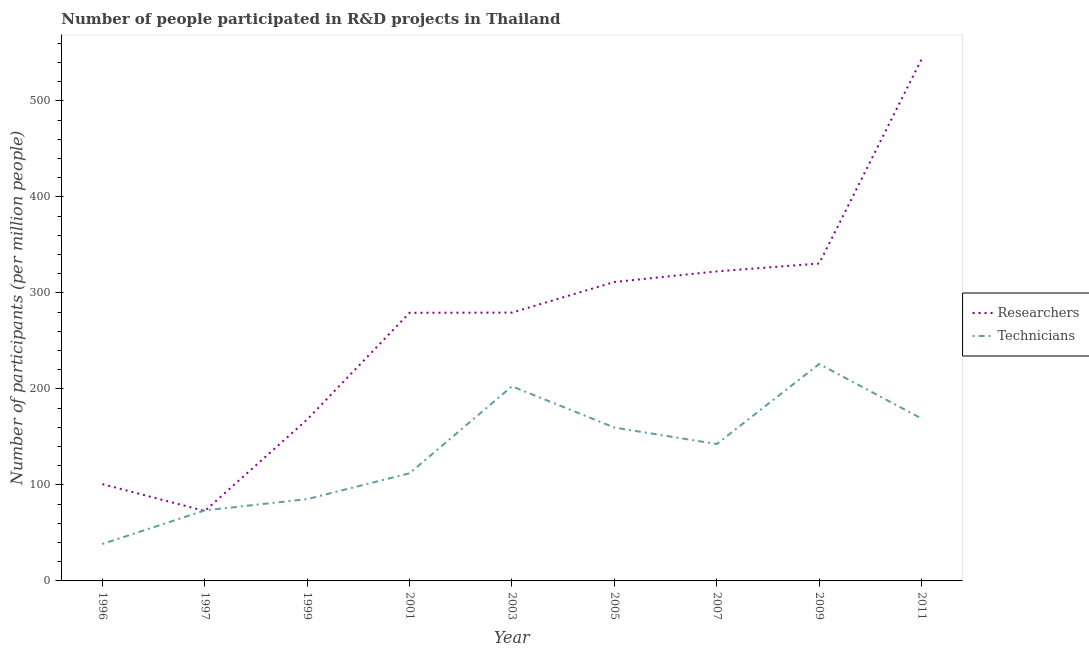Is the number of lines equal to the number of legend labels?
Provide a short and direct response. Yes. What is the number of technicians in 1997?
Your response must be concise. 73.43. Across all years, what is the maximum number of technicians?
Provide a succinct answer. 225.94. Across all years, what is the minimum number of researchers?
Keep it short and to the point. 72.82. What is the total number of researchers in the graph?
Your answer should be very brief. 2408.29. What is the difference between the number of technicians in 1996 and that in 2003?
Give a very brief answer. -164.25. What is the difference between the number of technicians in 1997 and the number of researchers in 2011?
Offer a terse response. -470.04. What is the average number of researchers per year?
Make the answer very short. 267.59. In the year 1996, what is the difference between the number of researchers and number of technicians?
Your response must be concise. 62.38. What is the ratio of the number of researchers in 1999 to that in 2007?
Provide a succinct answer. 0.52. Is the number of researchers in 1997 less than that in 2007?
Offer a terse response. Yes. What is the difference between the highest and the second highest number of technicians?
Offer a very short reply. 23.23. What is the difference between the highest and the lowest number of researchers?
Make the answer very short. 470.65. In how many years, is the number of technicians greater than the average number of technicians taken over all years?
Make the answer very short. 5. Does the number of technicians monotonically increase over the years?
Your answer should be compact. No. Is the number of researchers strictly greater than the number of technicians over the years?
Provide a succinct answer. No. Is the number of technicians strictly less than the number of researchers over the years?
Your answer should be very brief. No. What is the difference between two consecutive major ticks on the Y-axis?
Give a very brief answer. 100. Does the graph contain grids?
Ensure brevity in your answer.  No. Where does the legend appear in the graph?
Make the answer very short. Center right. How are the legend labels stacked?
Offer a very short reply. Vertical. What is the title of the graph?
Your answer should be compact. Number of people participated in R&D projects in Thailand. What is the label or title of the X-axis?
Your answer should be very brief. Year. What is the label or title of the Y-axis?
Your answer should be very brief. Number of participants (per million people). What is the Number of participants (per million people) of Researchers in 1996?
Make the answer very short. 100.84. What is the Number of participants (per million people) of Technicians in 1996?
Offer a very short reply. 38.46. What is the Number of participants (per million people) of Researchers in 1997?
Your answer should be compact. 72.82. What is the Number of participants (per million people) in Technicians in 1997?
Provide a short and direct response. 73.43. What is the Number of participants (per million people) of Researchers in 1999?
Keep it short and to the point. 168.1. What is the Number of participants (per million people) in Technicians in 1999?
Provide a short and direct response. 85.21. What is the Number of participants (per million people) in Researchers in 2001?
Ensure brevity in your answer.  279.27. What is the Number of participants (per million people) of Technicians in 2001?
Your answer should be compact. 112.12. What is the Number of participants (per million people) of Researchers in 2003?
Offer a very short reply. 279.46. What is the Number of participants (per million people) in Technicians in 2003?
Offer a terse response. 202.71. What is the Number of participants (per million people) of Researchers in 2005?
Ensure brevity in your answer.  311.34. What is the Number of participants (per million people) in Technicians in 2005?
Your answer should be very brief. 159.72. What is the Number of participants (per million people) of Researchers in 2007?
Offer a very short reply. 322.39. What is the Number of participants (per million people) of Technicians in 2007?
Offer a terse response. 142.58. What is the Number of participants (per million people) in Researchers in 2009?
Give a very brief answer. 330.59. What is the Number of participants (per million people) in Technicians in 2009?
Ensure brevity in your answer.  225.94. What is the Number of participants (per million people) in Researchers in 2011?
Give a very brief answer. 543.47. What is the Number of participants (per million people) in Technicians in 2011?
Give a very brief answer. 169.1. Across all years, what is the maximum Number of participants (per million people) in Researchers?
Give a very brief answer. 543.47. Across all years, what is the maximum Number of participants (per million people) of Technicians?
Your answer should be compact. 225.94. Across all years, what is the minimum Number of participants (per million people) in Researchers?
Provide a succinct answer. 72.82. Across all years, what is the minimum Number of participants (per million people) of Technicians?
Give a very brief answer. 38.46. What is the total Number of participants (per million people) of Researchers in the graph?
Give a very brief answer. 2408.29. What is the total Number of participants (per million people) of Technicians in the graph?
Your answer should be compact. 1209.28. What is the difference between the Number of participants (per million people) of Researchers in 1996 and that in 1997?
Your response must be concise. 28.01. What is the difference between the Number of participants (per million people) of Technicians in 1996 and that in 1997?
Offer a terse response. -34.97. What is the difference between the Number of participants (per million people) in Researchers in 1996 and that in 1999?
Provide a succinct answer. -67.27. What is the difference between the Number of participants (per million people) of Technicians in 1996 and that in 1999?
Offer a terse response. -46.75. What is the difference between the Number of participants (per million people) of Researchers in 1996 and that in 2001?
Provide a short and direct response. -178.43. What is the difference between the Number of participants (per million people) of Technicians in 1996 and that in 2001?
Keep it short and to the point. -73.66. What is the difference between the Number of participants (per million people) in Researchers in 1996 and that in 2003?
Your answer should be very brief. -178.63. What is the difference between the Number of participants (per million people) in Technicians in 1996 and that in 2003?
Offer a very short reply. -164.25. What is the difference between the Number of participants (per million people) in Researchers in 1996 and that in 2005?
Make the answer very short. -210.5. What is the difference between the Number of participants (per million people) in Technicians in 1996 and that in 2005?
Your response must be concise. -121.26. What is the difference between the Number of participants (per million people) in Researchers in 1996 and that in 2007?
Your answer should be compact. -221.56. What is the difference between the Number of participants (per million people) of Technicians in 1996 and that in 2007?
Ensure brevity in your answer.  -104.12. What is the difference between the Number of participants (per million people) of Researchers in 1996 and that in 2009?
Provide a short and direct response. -229.75. What is the difference between the Number of participants (per million people) in Technicians in 1996 and that in 2009?
Your answer should be compact. -187.48. What is the difference between the Number of participants (per million people) in Researchers in 1996 and that in 2011?
Ensure brevity in your answer.  -442.64. What is the difference between the Number of participants (per million people) in Technicians in 1996 and that in 2011?
Provide a short and direct response. -130.63. What is the difference between the Number of participants (per million people) of Researchers in 1997 and that in 1999?
Give a very brief answer. -95.28. What is the difference between the Number of participants (per million people) of Technicians in 1997 and that in 1999?
Offer a terse response. -11.78. What is the difference between the Number of participants (per million people) of Researchers in 1997 and that in 2001?
Your answer should be compact. -206.45. What is the difference between the Number of participants (per million people) in Technicians in 1997 and that in 2001?
Your answer should be compact. -38.69. What is the difference between the Number of participants (per million people) of Researchers in 1997 and that in 2003?
Offer a very short reply. -206.64. What is the difference between the Number of participants (per million people) in Technicians in 1997 and that in 2003?
Provide a short and direct response. -129.28. What is the difference between the Number of participants (per million people) in Researchers in 1997 and that in 2005?
Your answer should be compact. -238.52. What is the difference between the Number of participants (per million people) of Technicians in 1997 and that in 2005?
Ensure brevity in your answer.  -86.29. What is the difference between the Number of participants (per million people) of Researchers in 1997 and that in 2007?
Ensure brevity in your answer.  -249.57. What is the difference between the Number of participants (per million people) in Technicians in 1997 and that in 2007?
Your answer should be compact. -69.15. What is the difference between the Number of participants (per million people) of Researchers in 1997 and that in 2009?
Keep it short and to the point. -257.77. What is the difference between the Number of participants (per million people) of Technicians in 1997 and that in 2009?
Ensure brevity in your answer.  -152.51. What is the difference between the Number of participants (per million people) of Researchers in 1997 and that in 2011?
Offer a terse response. -470.65. What is the difference between the Number of participants (per million people) of Technicians in 1997 and that in 2011?
Your answer should be very brief. -95.66. What is the difference between the Number of participants (per million people) of Researchers in 1999 and that in 2001?
Offer a very short reply. -111.17. What is the difference between the Number of participants (per million people) in Technicians in 1999 and that in 2001?
Your answer should be compact. -26.91. What is the difference between the Number of participants (per million people) in Researchers in 1999 and that in 2003?
Make the answer very short. -111.36. What is the difference between the Number of participants (per million people) in Technicians in 1999 and that in 2003?
Give a very brief answer. -117.5. What is the difference between the Number of participants (per million people) in Researchers in 1999 and that in 2005?
Your answer should be very brief. -143.24. What is the difference between the Number of participants (per million people) of Technicians in 1999 and that in 2005?
Your answer should be very brief. -74.51. What is the difference between the Number of participants (per million people) in Researchers in 1999 and that in 2007?
Your response must be concise. -154.29. What is the difference between the Number of participants (per million people) in Technicians in 1999 and that in 2007?
Your response must be concise. -57.37. What is the difference between the Number of participants (per million people) in Researchers in 1999 and that in 2009?
Offer a very short reply. -162.48. What is the difference between the Number of participants (per million people) in Technicians in 1999 and that in 2009?
Give a very brief answer. -140.73. What is the difference between the Number of participants (per million people) in Researchers in 1999 and that in 2011?
Provide a succinct answer. -375.37. What is the difference between the Number of participants (per million people) in Technicians in 1999 and that in 2011?
Make the answer very short. -83.88. What is the difference between the Number of participants (per million people) in Researchers in 2001 and that in 2003?
Provide a succinct answer. -0.19. What is the difference between the Number of participants (per million people) of Technicians in 2001 and that in 2003?
Make the answer very short. -90.59. What is the difference between the Number of participants (per million people) in Researchers in 2001 and that in 2005?
Keep it short and to the point. -32.07. What is the difference between the Number of participants (per million people) of Technicians in 2001 and that in 2005?
Make the answer very short. -47.6. What is the difference between the Number of participants (per million people) of Researchers in 2001 and that in 2007?
Keep it short and to the point. -43.12. What is the difference between the Number of participants (per million people) of Technicians in 2001 and that in 2007?
Ensure brevity in your answer.  -30.47. What is the difference between the Number of participants (per million people) of Researchers in 2001 and that in 2009?
Your answer should be compact. -51.32. What is the difference between the Number of participants (per million people) in Technicians in 2001 and that in 2009?
Your response must be concise. -113.82. What is the difference between the Number of participants (per million people) of Researchers in 2001 and that in 2011?
Make the answer very short. -264.2. What is the difference between the Number of participants (per million people) in Technicians in 2001 and that in 2011?
Provide a short and direct response. -56.98. What is the difference between the Number of participants (per million people) of Researchers in 2003 and that in 2005?
Keep it short and to the point. -31.88. What is the difference between the Number of participants (per million people) in Technicians in 2003 and that in 2005?
Provide a succinct answer. 42.99. What is the difference between the Number of participants (per million people) in Researchers in 2003 and that in 2007?
Your answer should be very brief. -42.93. What is the difference between the Number of participants (per million people) in Technicians in 2003 and that in 2007?
Your answer should be compact. 60.12. What is the difference between the Number of participants (per million people) of Researchers in 2003 and that in 2009?
Keep it short and to the point. -51.12. What is the difference between the Number of participants (per million people) in Technicians in 2003 and that in 2009?
Provide a succinct answer. -23.23. What is the difference between the Number of participants (per million people) in Researchers in 2003 and that in 2011?
Your response must be concise. -264.01. What is the difference between the Number of participants (per million people) of Technicians in 2003 and that in 2011?
Offer a very short reply. 33.61. What is the difference between the Number of participants (per million people) of Researchers in 2005 and that in 2007?
Give a very brief answer. -11.06. What is the difference between the Number of participants (per million people) of Technicians in 2005 and that in 2007?
Your answer should be compact. 17.14. What is the difference between the Number of participants (per million people) in Researchers in 2005 and that in 2009?
Offer a very short reply. -19.25. What is the difference between the Number of participants (per million people) of Technicians in 2005 and that in 2009?
Provide a succinct answer. -66.22. What is the difference between the Number of participants (per million people) of Researchers in 2005 and that in 2011?
Provide a short and direct response. -232.14. What is the difference between the Number of participants (per million people) of Technicians in 2005 and that in 2011?
Offer a terse response. -9.37. What is the difference between the Number of participants (per million people) of Researchers in 2007 and that in 2009?
Keep it short and to the point. -8.19. What is the difference between the Number of participants (per million people) in Technicians in 2007 and that in 2009?
Provide a short and direct response. -83.36. What is the difference between the Number of participants (per million people) in Researchers in 2007 and that in 2011?
Ensure brevity in your answer.  -221.08. What is the difference between the Number of participants (per million people) in Technicians in 2007 and that in 2011?
Provide a succinct answer. -26.51. What is the difference between the Number of participants (per million people) in Researchers in 2009 and that in 2011?
Offer a very short reply. -212.89. What is the difference between the Number of participants (per million people) of Technicians in 2009 and that in 2011?
Keep it short and to the point. 56.85. What is the difference between the Number of participants (per million people) in Researchers in 1996 and the Number of participants (per million people) in Technicians in 1997?
Make the answer very short. 27.4. What is the difference between the Number of participants (per million people) of Researchers in 1996 and the Number of participants (per million people) of Technicians in 1999?
Your answer should be compact. 15.62. What is the difference between the Number of participants (per million people) in Researchers in 1996 and the Number of participants (per million people) in Technicians in 2001?
Your response must be concise. -11.28. What is the difference between the Number of participants (per million people) in Researchers in 1996 and the Number of participants (per million people) in Technicians in 2003?
Provide a short and direct response. -101.87. What is the difference between the Number of participants (per million people) of Researchers in 1996 and the Number of participants (per million people) of Technicians in 2005?
Offer a terse response. -58.89. What is the difference between the Number of participants (per million people) in Researchers in 1996 and the Number of participants (per million people) in Technicians in 2007?
Make the answer very short. -41.75. What is the difference between the Number of participants (per million people) in Researchers in 1996 and the Number of participants (per million people) in Technicians in 2009?
Provide a succinct answer. -125.1. What is the difference between the Number of participants (per million people) in Researchers in 1996 and the Number of participants (per million people) in Technicians in 2011?
Keep it short and to the point. -68.26. What is the difference between the Number of participants (per million people) in Researchers in 1997 and the Number of participants (per million people) in Technicians in 1999?
Make the answer very short. -12.39. What is the difference between the Number of participants (per million people) of Researchers in 1997 and the Number of participants (per million people) of Technicians in 2001?
Your answer should be compact. -39.3. What is the difference between the Number of participants (per million people) of Researchers in 1997 and the Number of participants (per million people) of Technicians in 2003?
Offer a terse response. -129.89. What is the difference between the Number of participants (per million people) of Researchers in 1997 and the Number of participants (per million people) of Technicians in 2005?
Keep it short and to the point. -86.9. What is the difference between the Number of participants (per million people) in Researchers in 1997 and the Number of participants (per million people) in Technicians in 2007?
Your answer should be compact. -69.76. What is the difference between the Number of participants (per million people) in Researchers in 1997 and the Number of participants (per million people) in Technicians in 2009?
Your answer should be very brief. -153.12. What is the difference between the Number of participants (per million people) of Researchers in 1997 and the Number of participants (per million people) of Technicians in 2011?
Offer a very short reply. -96.27. What is the difference between the Number of participants (per million people) in Researchers in 1999 and the Number of participants (per million people) in Technicians in 2001?
Your answer should be very brief. 55.98. What is the difference between the Number of participants (per million people) in Researchers in 1999 and the Number of participants (per million people) in Technicians in 2003?
Keep it short and to the point. -34.61. What is the difference between the Number of participants (per million people) in Researchers in 1999 and the Number of participants (per million people) in Technicians in 2005?
Your response must be concise. 8.38. What is the difference between the Number of participants (per million people) in Researchers in 1999 and the Number of participants (per million people) in Technicians in 2007?
Make the answer very short. 25.52. What is the difference between the Number of participants (per million people) of Researchers in 1999 and the Number of participants (per million people) of Technicians in 2009?
Your response must be concise. -57.84. What is the difference between the Number of participants (per million people) of Researchers in 1999 and the Number of participants (per million people) of Technicians in 2011?
Ensure brevity in your answer.  -0.99. What is the difference between the Number of participants (per million people) in Researchers in 2001 and the Number of participants (per million people) in Technicians in 2003?
Ensure brevity in your answer.  76.56. What is the difference between the Number of participants (per million people) in Researchers in 2001 and the Number of participants (per million people) in Technicians in 2005?
Your response must be concise. 119.55. What is the difference between the Number of participants (per million people) in Researchers in 2001 and the Number of participants (per million people) in Technicians in 2007?
Your response must be concise. 136.69. What is the difference between the Number of participants (per million people) in Researchers in 2001 and the Number of participants (per million people) in Technicians in 2009?
Your answer should be compact. 53.33. What is the difference between the Number of participants (per million people) in Researchers in 2001 and the Number of participants (per million people) in Technicians in 2011?
Your response must be concise. 110.17. What is the difference between the Number of participants (per million people) in Researchers in 2003 and the Number of participants (per million people) in Technicians in 2005?
Offer a terse response. 119.74. What is the difference between the Number of participants (per million people) of Researchers in 2003 and the Number of participants (per million people) of Technicians in 2007?
Provide a short and direct response. 136.88. What is the difference between the Number of participants (per million people) in Researchers in 2003 and the Number of participants (per million people) in Technicians in 2009?
Offer a very short reply. 53.52. What is the difference between the Number of participants (per million people) in Researchers in 2003 and the Number of participants (per million people) in Technicians in 2011?
Your answer should be compact. 110.37. What is the difference between the Number of participants (per million people) in Researchers in 2005 and the Number of participants (per million people) in Technicians in 2007?
Give a very brief answer. 168.75. What is the difference between the Number of participants (per million people) in Researchers in 2005 and the Number of participants (per million people) in Technicians in 2009?
Provide a short and direct response. 85.4. What is the difference between the Number of participants (per million people) in Researchers in 2005 and the Number of participants (per million people) in Technicians in 2011?
Your answer should be compact. 142.24. What is the difference between the Number of participants (per million people) in Researchers in 2007 and the Number of participants (per million people) in Technicians in 2009?
Keep it short and to the point. 96.45. What is the difference between the Number of participants (per million people) of Researchers in 2007 and the Number of participants (per million people) of Technicians in 2011?
Make the answer very short. 153.3. What is the difference between the Number of participants (per million people) in Researchers in 2009 and the Number of participants (per million people) in Technicians in 2011?
Your answer should be compact. 161.49. What is the average Number of participants (per million people) of Researchers per year?
Give a very brief answer. 267.59. What is the average Number of participants (per million people) of Technicians per year?
Offer a very short reply. 134.36. In the year 1996, what is the difference between the Number of participants (per million people) in Researchers and Number of participants (per million people) in Technicians?
Give a very brief answer. 62.38. In the year 1997, what is the difference between the Number of participants (per million people) of Researchers and Number of participants (per million people) of Technicians?
Keep it short and to the point. -0.61. In the year 1999, what is the difference between the Number of participants (per million people) of Researchers and Number of participants (per million people) of Technicians?
Ensure brevity in your answer.  82.89. In the year 2001, what is the difference between the Number of participants (per million people) in Researchers and Number of participants (per million people) in Technicians?
Your answer should be very brief. 167.15. In the year 2003, what is the difference between the Number of participants (per million people) in Researchers and Number of participants (per million people) in Technicians?
Make the answer very short. 76.75. In the year 2005, what is the difference between the Number of participants (per million people) in Researchers and Number of participants (per million people) in Technicians?
Make the answer very short. 151.62. In the year 2007, what is the difference between the Number of participants (per million people) in Researchers and Number of participants (per million people) in Technicians?
Make the answer very short. 179.81. In the year 2009, what is the difference between the Number of participants (per million people) in Researchers and Number of participants (per million people) in Technicians?
Provide a short and direct response. 104.65. In the year 2011, what is the difference between the Number of participants (per million people) in Researchers and Number of participants (per million people) in Technicians?
Provide a short and direct response. 374.38. What is the ratio of the Number of participants (per million people) of Researchers in 1996 to that in 1997?
Give a very brief answer. 1.38. What is the ratio of the Number of participants (per million people) of Technicians in 1996 to that in 1997?
Give a very brief answer. 0.52. What is the ratio of the Number of participants (per million people) of Researchers in 1996 to that in 1999?
Offer a terse response. 0.6. What is the ratio of the Number of participants (per million people) of Technicians in 1996 to that in 1999?
Make the answer very short. 0.45. What is the ratio of the Number of participants (per million people) in Researchers in 1996 to that in 2001?
Your answer should be compact. 0.36. What is the ratio of the Number of participants (per million people) in Technicians in 1996 to that in 2001?
Provide a short and direct response. 0.34. What is the ratio of the Number of participants (per million people) of Researchers in 1996 to that in 2003?
Make the answer very short. 0.36. What is the ratio of the Number of participants (per million people) of Technicians in 1996 to that in 2003?
Ensure brevity in your answer.  0.19. What is the ratio of the Number of participants (per million people) in Researchers in 1996 to that in 2005?
Keep it short and to the point. 0.32. What is the ratio of the Number of participants (per million people) of Technicians in 1996 to that in 2005?
Make the answer very short. 0.24. What is the ratio of the Number of participants (per million people) in Researchers in 1996 to that in 2007?
Ensure brevity in your answer.  0.31. What is the ratio of the Number of participants (per million people) in Technicians in 1996 to that in 2007?
Provide a succinct answer. 0.27. What is the ratio of the Number of participants (per million people) in Researchers in 1996 to that in 2009?
Ensure brevity in your answer.  0.3. What is the ratio of the Number of participants (per million people) of Technicians in 1996 to that in 2009?
Your answer should be very brief. 0.17. What is the ratio of the Number of participants (per million people) in Researchers in 1996 to that in 2011?
Keep it short and to the point. 0.19. What is the ratio of the Number of participants (per million people) of Technicians in 1996 to that in 2011?
Make the answer very short. 0.23. What is the ratio of the Number of participants (per million people) in Researchers in 1997 to that in 1999?
Your response must be concise. 0.43. What is the ratio of the Number of participants (per million people) in Technicians in 1997 to that in 1999?
Provide a succinct answer. 0.86. What is the ratio of the Number of participants (per million people) of Researchers in 1997 to that in 2001?
Ensure brevity in your answer.  0.26. What is the ratio of the Number of participants (per million people) in Technicians in 1997 to that in 2001?
Keep it short and to the point. 0.66. What is the ratio of the Number of participants (per million people) in Researchers in 1997 to that in 2003?
Your answer should be compact. 0.26. What is the ratio of the Number of participants (per million people) of Technicians in 1997 to that in 2003?
Provide a short and direct response. 0.36. What is the ratio of the Number of participants (per million people) of Researchers in 1997 to that in 2005?
Your answer should be compact. 0.23. What is the ratio of the Number of participants (per million people) in Technicians in 1997 to that in 2005?
Offer a terse response. 0.46. What is the ratio of the Number of participants (per million people) of Researchers in 1997 to that in 2007?
Keep it short and to the point. 0.23. What is the ratio of the Number of participants (per million people) of Technicians in 1997 to that in 2007?
Provide a succinct answer. 0.52. What is the ratio of the Number of participants (per million people) in Researchers in 1997 to that in 2009?
Your answer should be compact. 0.22. What is the ratio of the Number of participants (per million people) of Technicians in 1997 to that in 2009?
Keep it short and to the point. 0.33. What is the ratio of the Number of participants (per million people) of Researchers in 1997 to that in 2011?
Offer a terse response. 0.13. What is the ratio of the Number of participants (per million people) of Technicians in 1997 to that in 2011?
Your response must be concise. 0.43. What is the ratio of the Number of participants (per million people) of Researchers in 1999 to that in 2001?
Make the answer very short. 0.6. What is the ratio of the Number of participants (per million people) of Technicians in 1999 to that in 2001?
Keep it short and to the point. 0.76. What is the ratio of the Number of participants (per million people) of Researchers in 1999 to that in 2003?
Provide a succinct answer. 0.6. What is the ratio of the Number of participants (per million people) in Technicians in 1999 to that in 2003?
Offer a very short reply. 0.42. What is the ratio of the Number of participants (per million people) in Researchers in 1999 to that in 2005?
Keep it short and to the point. 0.54. What is the ratio of the Number of participants (per million people) of Technicians in 1999 to that in 2005?
Provide a succinct answer. 0.53. What is the ratio of the Number of participants (per million people) in Researchers in 1999 to that in 2007?
Provide a short and direct response. 0.52. What is the ratio of the Number of participants (per million people) in Technicians in 1999 to that in 2007?
Ensure brevity in your answer.  0.6. What is the ratio of the Number of participants (per million people) in Researchers in 1999 to that in 2009?
Your response must be concise. 0.51. What is the ratio of the Number of participants (per million people) of Technicians in 1999 to that in 2009?
Your answer should be very brief. 0.38. What is the ratio of the Number of participants (per million people) in Researchers in 1999 to that in 2011?
Give a very brief answer. 0.31. What is the ratio of the Number of participants (per million people) in Technicians in 1999 to that in 2011?
Provide a short and direct response. 0.5. What is the ratio of the Number of participants (per million people) of Researchers in 2001 to that in 2003?
Offer a terse response. 1. What is the ratio of the Number of participants (per million people) in Technicians in 2001 to that in 2003?
Ensure brevity in your answer.  0.55. What is the ratio of the Number of participants (per million people) in Researchers in 2001 to that in 2005?
Provide a succinct answer. 0.9. What is the ratio of the Number of participants (per million people) of Technicians in 2001 to that in 2005?
Your answer should be compact. 0.7. What is the ratio of the Number of participants (per million people) in Researchers in 2001 to that in 2007?
Your response must be concise. 0.87. What is the ratio of the Number of participants (per million people) in Technicians in 2001 to that in 2007?
Make the answer very short. 0.79. What is the ratio of the Number of participants (per million people) of Researchers in 2001 to that in 2009?
Your answer should be compact. 0.84. What is the ratio of the Number of participants (per million people) in Technicians in 2001 to that in 2009?
Your answer should be very brief. 0.5. What is the ratio of the Number of participants (per million people) in Researchers in 2001 to that in 2011?
Provide a succinct answer. 0.51. What is the ratio of the Number of participants (per million people) in Technicians in 2001 to that in 2011?
Keep it short and to the point. 0.66. What is the ratio of the Number of participants (per million people) of Researchers in 2003 to that in 2005?
Make the answer very short. 0.9. What is the ratio of the Number of participants (per million people) in Technicians in 2003 to that in 2005?
Your answer should be compact. 1.27. What is the ratio of the Number of participants (per million people) in Researchers in 2003 to that in 2007?
Keep it short and to the point. 0.87. What is the ratio of the Number of participants (per million people) of Technicians in 2003 to that in 2007?
Your response must be concise. 1.42. What is the ratio of the Number of participants (per million people) of Researchers in 2003 to that in 2009?
Offer a terse response. 0.85. What is the ratio of the Number of participants (per million people) in Technicians in 2003 to that in 2009?
Keep it short and to the point. 0.9. What is the ratio of the Number of participants (per million people) of Researchers in 2003 to that in 2011?
Your answer should be compact. 0.51. What is the ratio of the Number of participants (per million people) in Technicians in 2003 to that in 2011?
Keep it short and to the point. 1.2. What is the ratio of the Number of participants (per million people) in Researchers in 2005 to that in 2007?
Provide a succinct answer. 0.97. What is the ratio of the Number of participants (per million people) of Technicians in 2005 to that in 2007?
Keep it short and to the point. 1.12. What is the ratio of the Number of participants (per million people) of Researchers in 2005 to that in 2009?
Your answer should be compact. 0.94. What is the ratio of the Number of participants (per million people) in Technicians in 2005 to that in 2009?
Provide a short and direct response. 0.71. What is the ratio of the Number of participants (per million people) in Researchers in 2005 to that in 2011?
Offer a very short reply. 0.57. What is the ratio of the Number of participants (per million people) in Technicians in 2005 to that in 2011?
Make the answer very short. 0.94. What is the ratio of the Number of participants (per million people) of Researchers in 2007 to that in 2009?
Provide a succinct answer. 0.98. What is the ratio of the Number of participants (per million people) of Technicians in 2007 to that in 2009?
Provide a succinct answer. 0.63. What is the ratio of the Number of participants (per million people) in Researchers in 2007 to that in 2011?
Your answer should be compact. 0.59. What is the ratio of the Number of participants (per million people) of Technicians in 2007 to that in 2011?
Make the answer very short. 0.84. What is the ratio of the Number of participants (per million people) of Researchers in 2009 to that in 2011?
Offer a very short reply. 0.61. What is the ratio of the Number of participants (per million people) of Technicians in 2009 to that in 2011?
Offer a very short reply. 1.34. What is the difference between the highest and the second highest Number of participants (per million people) in Researchers?
Keep it short and to the point. 212.89. What is the difference between the highest and the second highest Number of participants (per million people) in Technicians?
Give a very brief answer. 23.23. What is the difference between the highest and the lowest Number of participants (per million people) of Researchers?
Offer a very short reply. 470.65. What is the difference between the highest and the lowest Number of participants (per million people) of Technicians?
Your response must be concise. 187.48. 